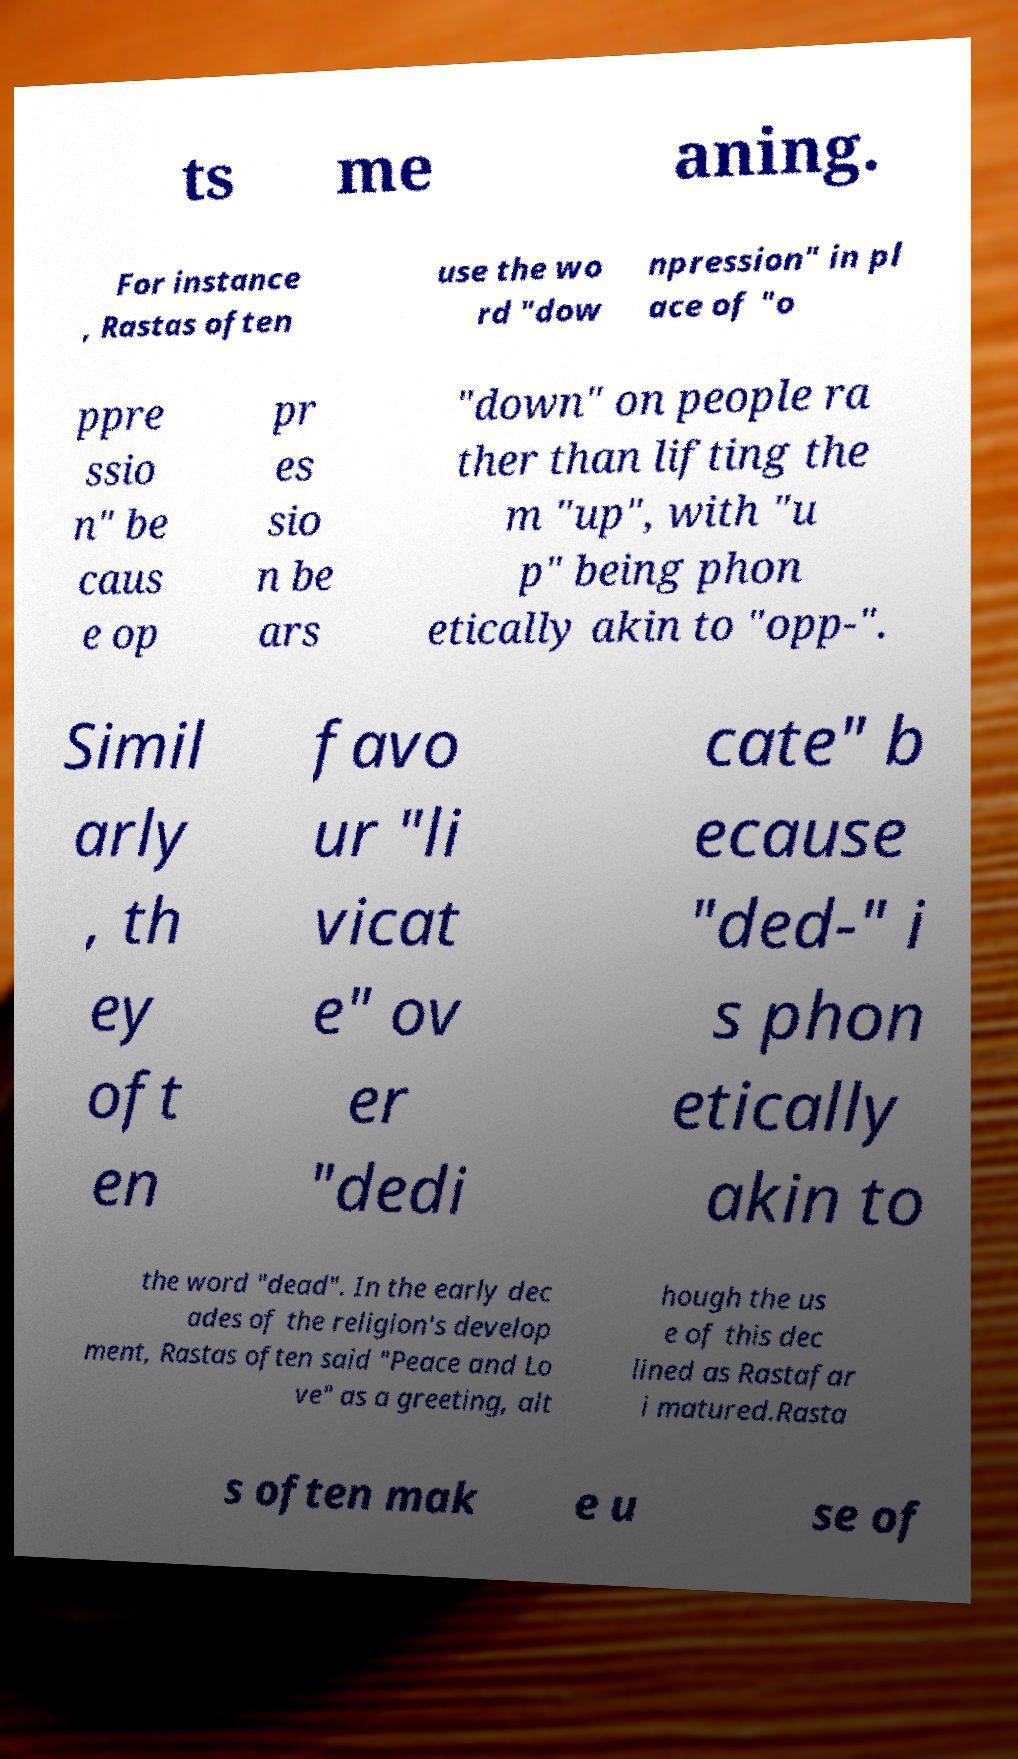Please identify and transcribe the text found in this image. ts me aning. For instance , Rastas often use the wo rd "dow npression" in pl ace of "o ppre ssio n" be caus e op pr es sio n be ars "down" on people ra ther than lifting the m "up", with "u p" being phon etically akin to "opp-". Simil arly , th ey oft en favo ur "li vicat e" ov er "dedi cate" b ecause "ded-" i s phon etically akin to the word "dead". In the early dec ades of the religion's develop ment, Rastas often said "Peace and Lo ve" as a greeting, alt hough the us e of this dec lined as Rastafar i matured.Rasta s often mak e u se of 